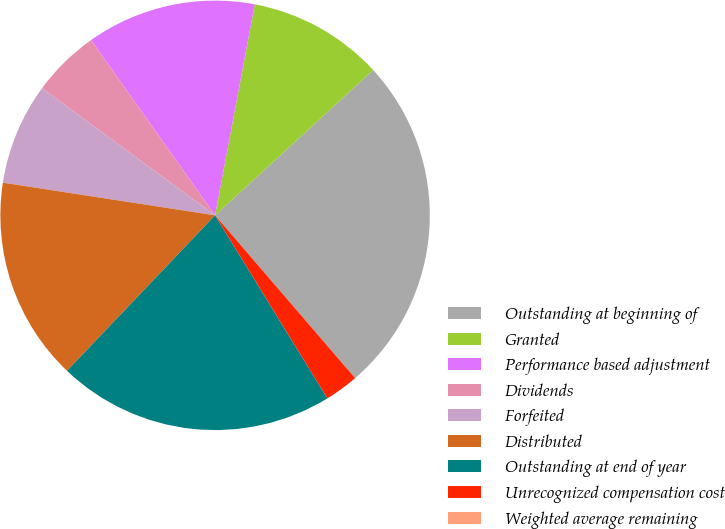Convert chart. <chart><loc_0><loc_0><loc_500><loc_500><pie_chart><fcel>Outstanding at beginning of<fcel>Granted<fcel>Performance based adjustment<fcel>Dividends<fcel>Forfeited<fcel>Distributed<fcel>Outstanding at end of year<fcel>Unrecognized compensation cost<fcel>Weighted average remaining<nl><fcel>25.53%<fcel>10.21%<fcel>12.76%<fcel>5.11%<fcel>7.66%<fcel>15.32%<fcel>20.87%<fcel>2.55%<fcel>0.0%<nl></chart> 